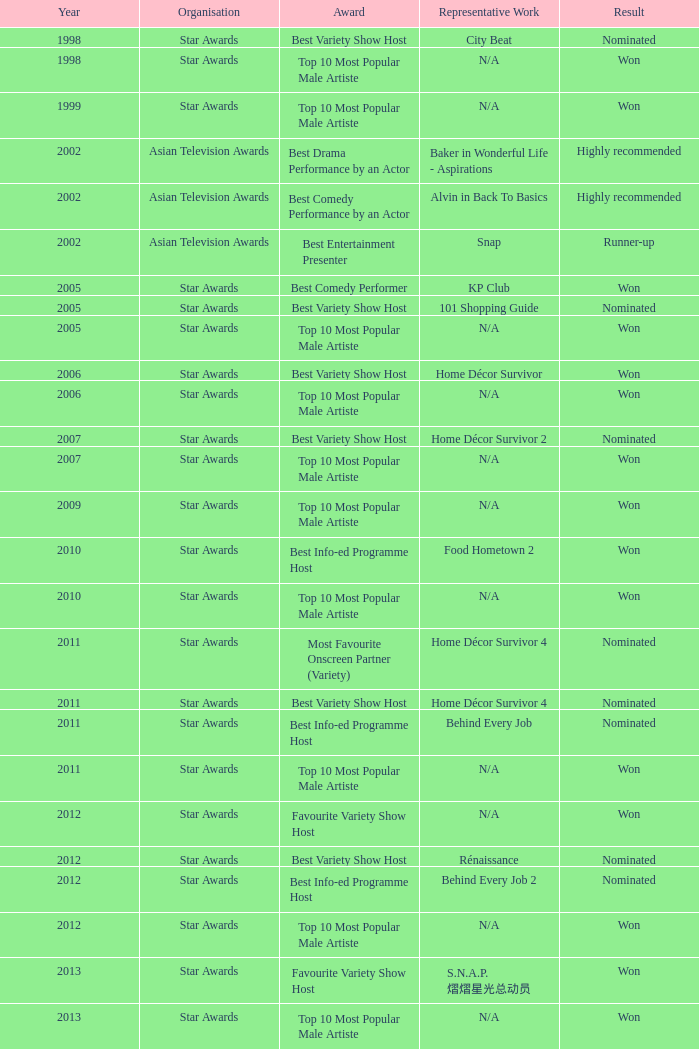What is the designation of the award in a year after 2005, and the consequence of nominated? Best Variety Show Host, Most Favourite Onscreen Partner (Variety), Best Variety Show Host, Best Info-ed Programme Host, Best Variety Show Host, Best Info-ed Programme Host, Best Info-Ed Programme Host, Best Variety Show Host. 